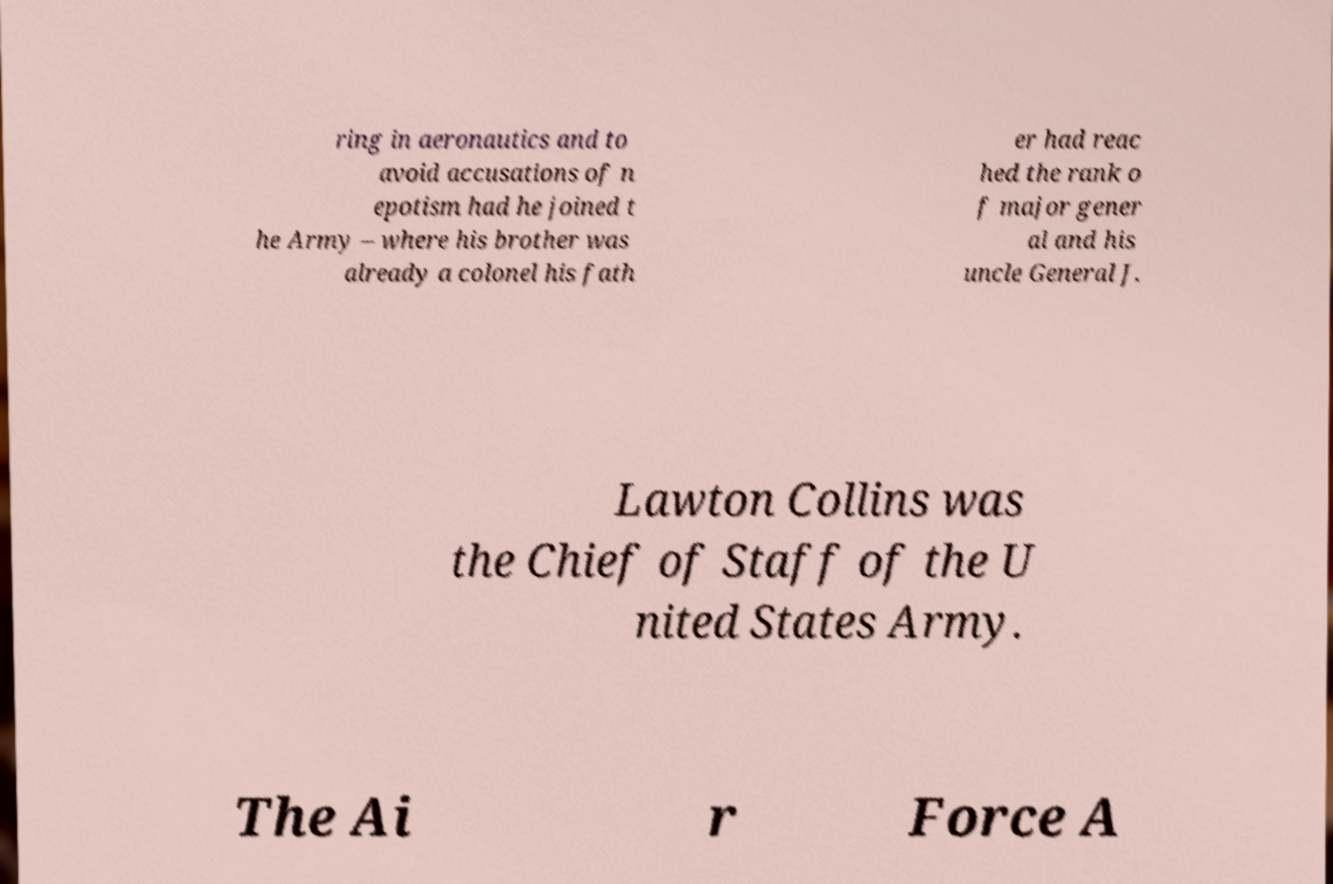Could you assist in decoding the text presented in this image and type it out clearly? ring in aeronautics and to avoid accusations of n epotism had he joined t he Army – where his brother was already a colonel his fath er had reac hed the rank o f major gener al and his uncle General J. Lawton Collins was the Chief of Staff of the U nited States Army. The Ai r Force A 